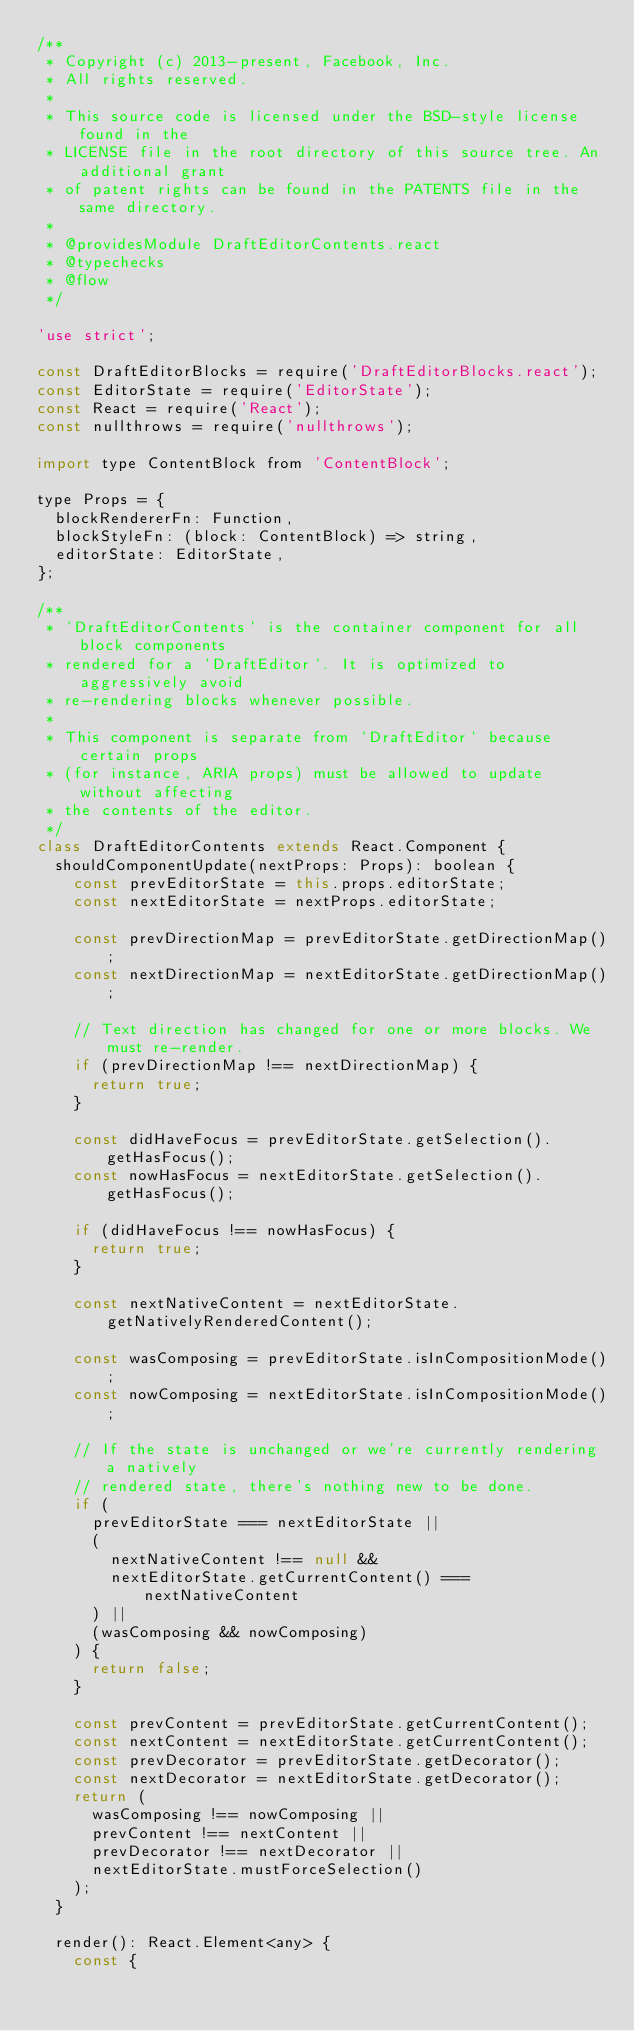Convert code to text. <code><loc_0><loc_0><loc_500><loc_500><_JavaScript_>/**
 * Copyright (c) 2013-present, Facebook, Inc.
 * All rights reserved.
 *
 * This source code is licensed under the BSD-style license found in the
 * LICENSE file in the root directory of this source tree. An additional grant
 * of patent rights can be found in the PATENTS file in the same directory.
 *
 * @providesModule DraftEditorContents.react
 * @typechecks
 * @flow
 */

'use strict';

const DraftEditorBlocks = require('DraftEditorBlocks.react');
const EditorState = require('EditorState');
const React = require('React');
const nullthrows = require('nullthrows');

import type ContentBlock from 'ContentBlock';

type Props = {
  blockRendererFn: Function,
  blockStyleFn: (block: ContentBlock) => string,
  editorState: EditorState,
};

/**
 * `DraftEditorContents` is the container component for all block components
 * rendered for a `DraftEditor`. It is optimized to aggressively avoid
 * re-rendering blocks whenever possible.
 *
 * This component is separate from `DraftEditor` because certain props
 * (for instance, ARIA props) must be allowed to update without affecting
 * the contents of the editor.
 */
class DraftEditorContents extends React.Component {
  shouldComponentUpdate(nextProps: Props): boolean {
    const prevEditorState = this.props.editorState;
    const nextEditorState = nextProps.editorState;

    const prevDirectionMap = prevEditorState.getDirectionMap();
    const nextDirectionMap = nextEditorState.getDirectionMap();

    // Text direction has changed for one or more blocks. We must re-render.
    if (prevDirectionMap !== nextDirectionMap) {
      return true;
    }

    const didHaveFocus = prevEditorState.getSelection().getHasFocus();
    const nowHasFocus = nextEditorState.getSelection().getHasFocus();

    if (didHaveFocus !== nowHasFocus) {
      return true;
    }

    const nextNativeContent = nextEditorState.getNativelyRenderedContent();

    const wasComposing = prevEditorState.isInCompositionMode();
    const nowComposing = nextEditorState.isInCompositionMode();

    // If the state is unchanged or we're currently rendering a natively
    // rendered state, there's nothing new to be done.
    if (
      prevEditorState === nextEditorState ||
      (
        nextNativeContent !== null &&
        nextEditorState.getCurrentContent() === nextNativeContent
      ) ||
      (wasComposing && nowComposing)
    ) {
      return false;
    }

    const prevContent = prevEditorState.getCurrentContent();
    const nextContent = nextEditorState.getCurrentContent();
    const prevDecorator = prevEditorState.getDecorator();
    const nextDecorator = nextEditorState.getDecorator();
    return (
      wasComposing !== nowComposing ||
      prevContent !== nextContent ||
      prevDecorator !== nextDecorator ||
      nextEditorState.mustForceSelection()
    );
  }

  render(): React.Element<any> {
    const {</code> 